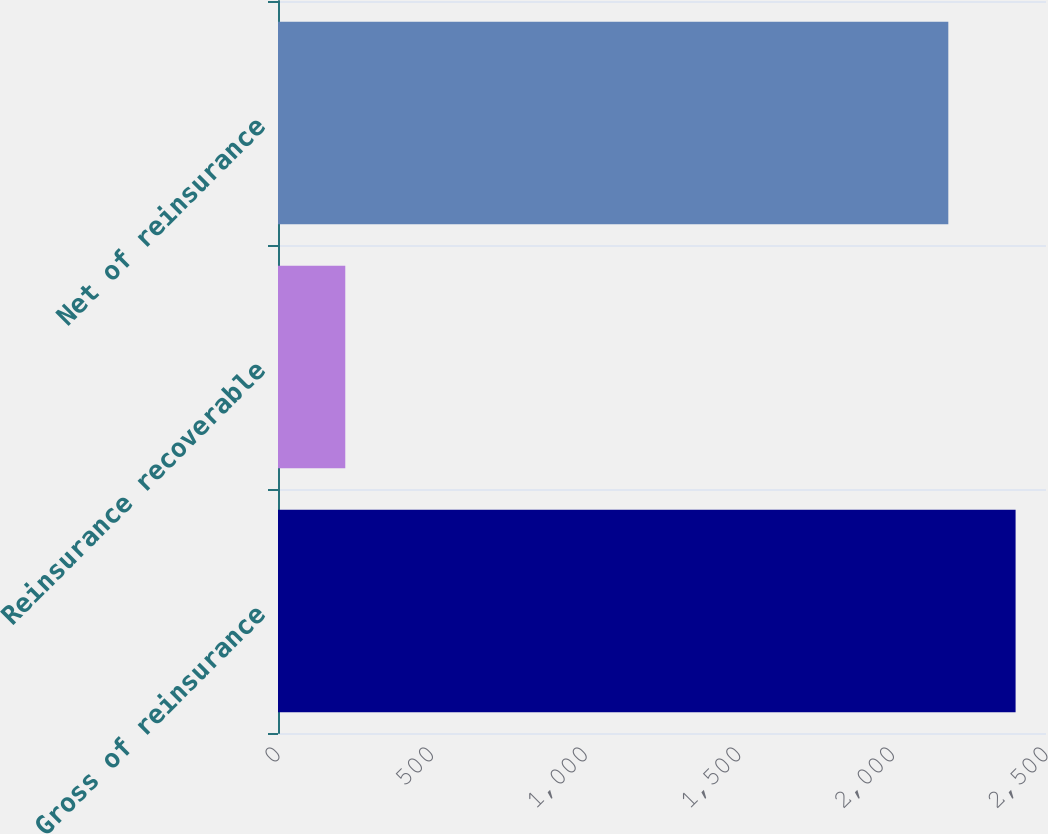Convert chart to OTSL. <chart><loc_0><loc_0><loc_500><loc_500><bar_chart><fcel>Gross of reinsurance<fcel>Reinsurance recoverable<fcel>Net of reinsurance<nl><fcel>2401<fcel>219<fcel>2182<nl></chart> 